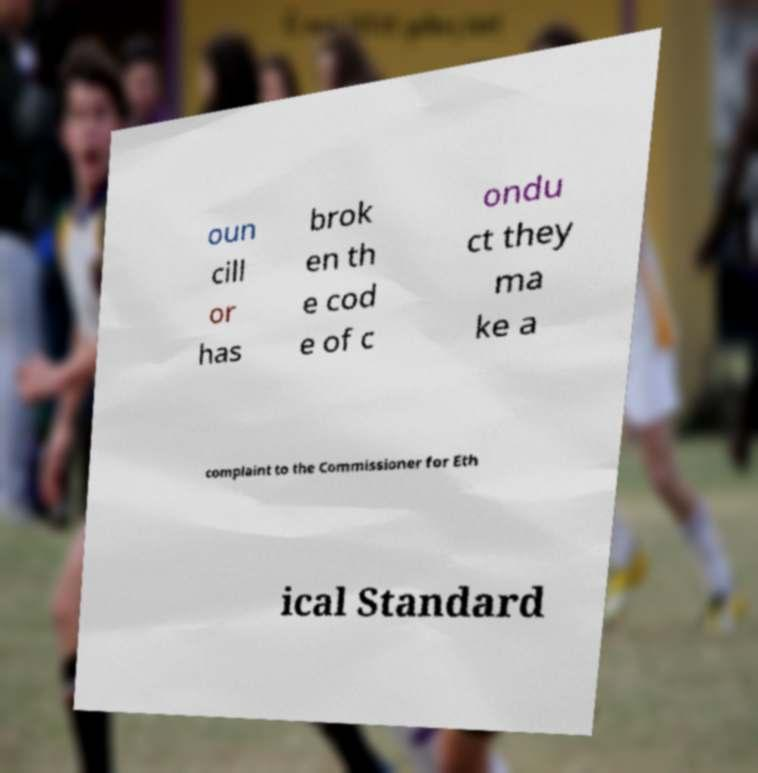Could you assist in decoding the text presented in this image and type it out clearly? oun cill or has brok en th e cod e of c ondu ct they ma ke a complaint to the Commissioner for Eth ical Standard 